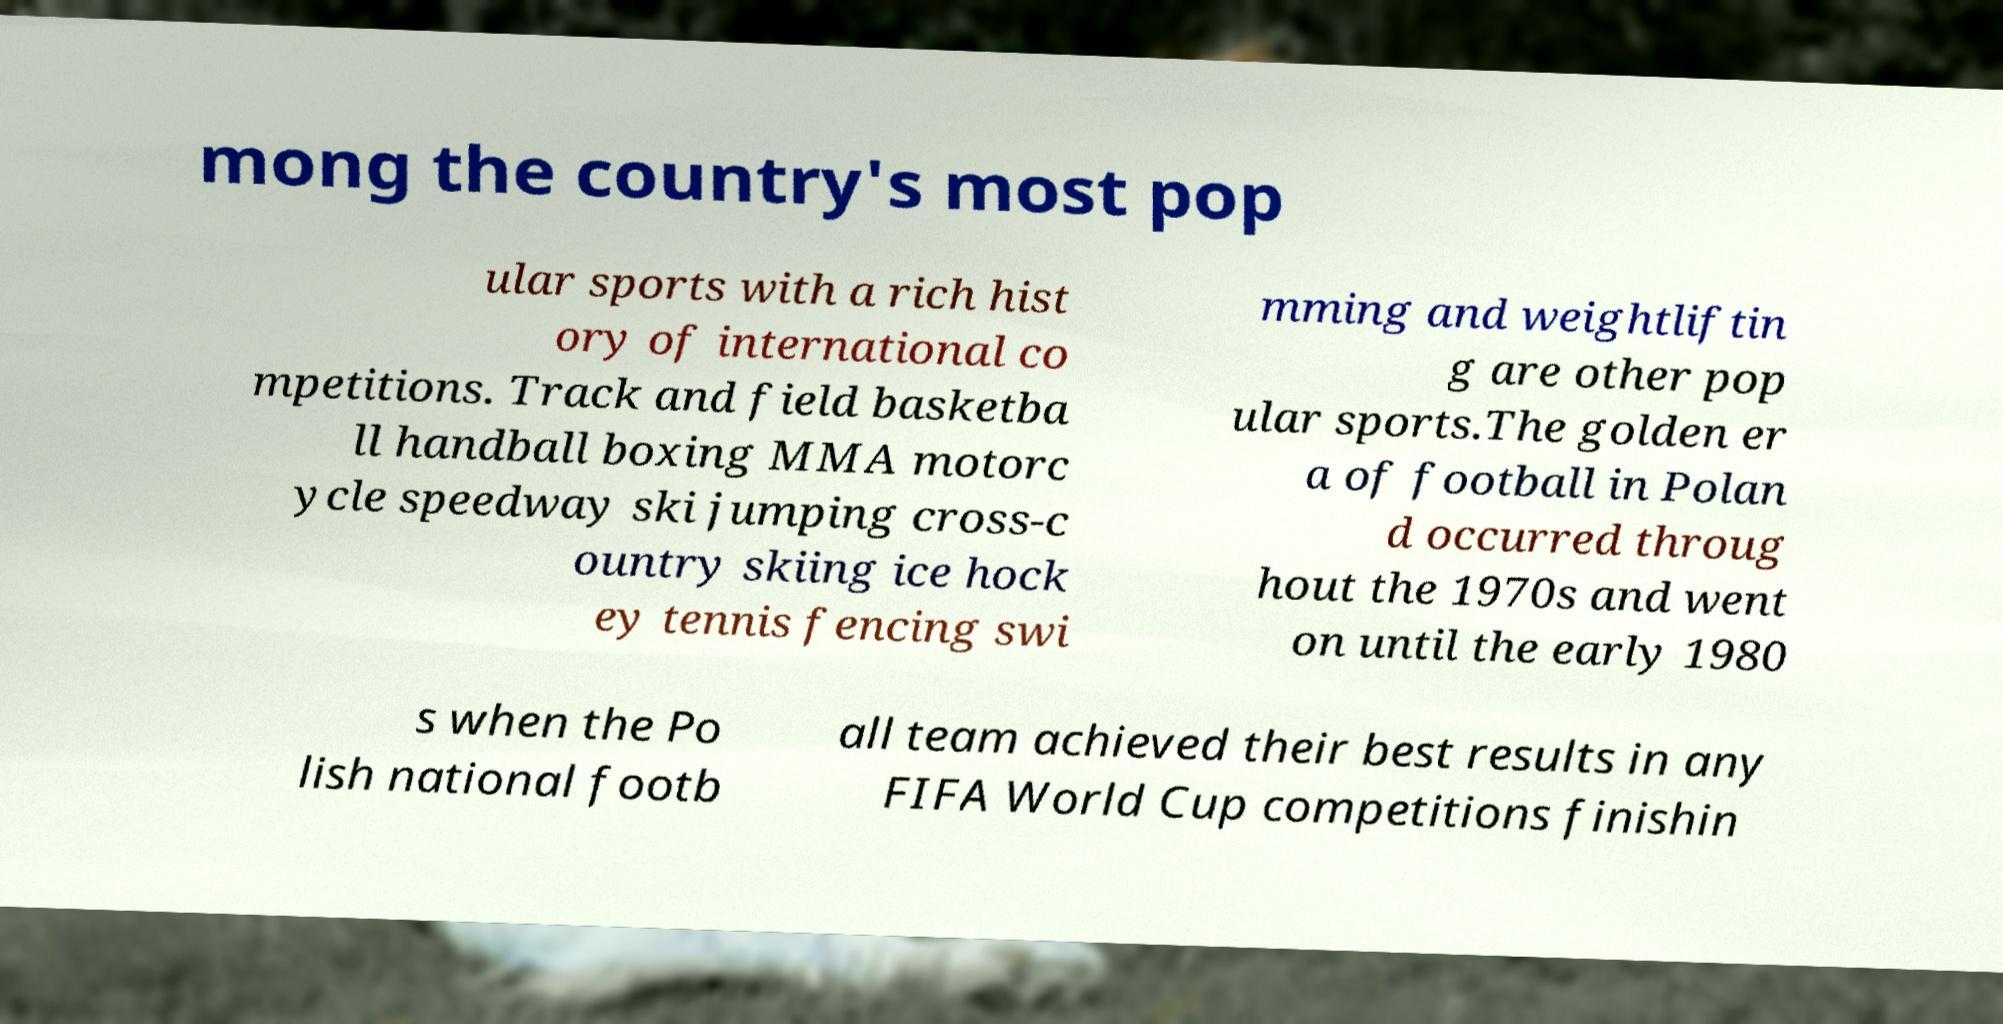Please read and relay the text visible in this image. What does it say? mong the country's most pop ular sports with a rich hist ory of international co mpetitions. Track and field basketba ll handball boxing MMA motorc ycle speedway ski jumping cross-c ountry skiing ice hock ey tennis fencing swi mming and weightliftin g are other pop ular sports.The golden er a of football in Polan d occurred throug hout the 1970s and went on until the early 1980 s when the Po lish national footb all team achieved their best results in any FIFA World Cup competitions finishin 